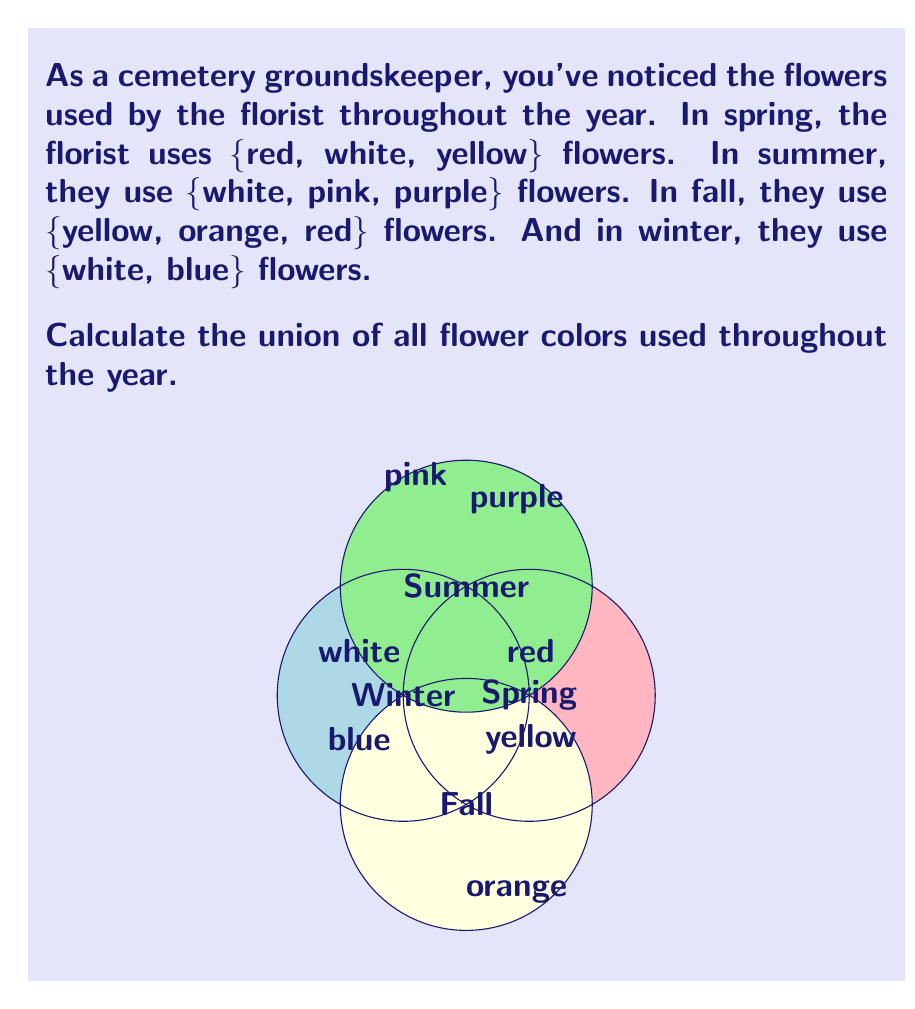Teach me how to tackle this problem. To solve this problem, we need to find the union of all sets of flower colors used in each season. Let's approach this step-by-step:

1) First, let's define our sets:
   Spring (S) = {red, white, yellow}
   Summer (M) = {white, pink, purple}
   Fall (F) = {yellow, orange, red}
   Winter (W) = {white, blue}

2) We need to find $S \cup M \cup F \cup W$

3) Let's start combining these sets:
   $S \cup M = \{red, white, yellow, pink, purple\}$

4) Now let's add F:
   $(S \cup M) \cup F = \{red, white, yellow, pink, purple, orange\}$

5) Finally, let's add W:
   $((S \cup M) \cup F) \cup W = \{red, white, yellow, pink, purple, orange, blue\}$

6) We've now included all unique colors from all seasons.

Therefore, the union of all flower colors used throughout the year is {red, white, yellow, pink, purple, orange, blue}.
Answer: $\{red, white, yellow, pink, purple, orange, blue\}$ 